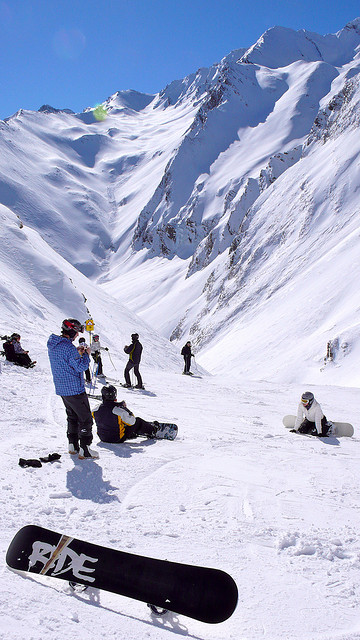Read and extract the text from this image. RIDE 